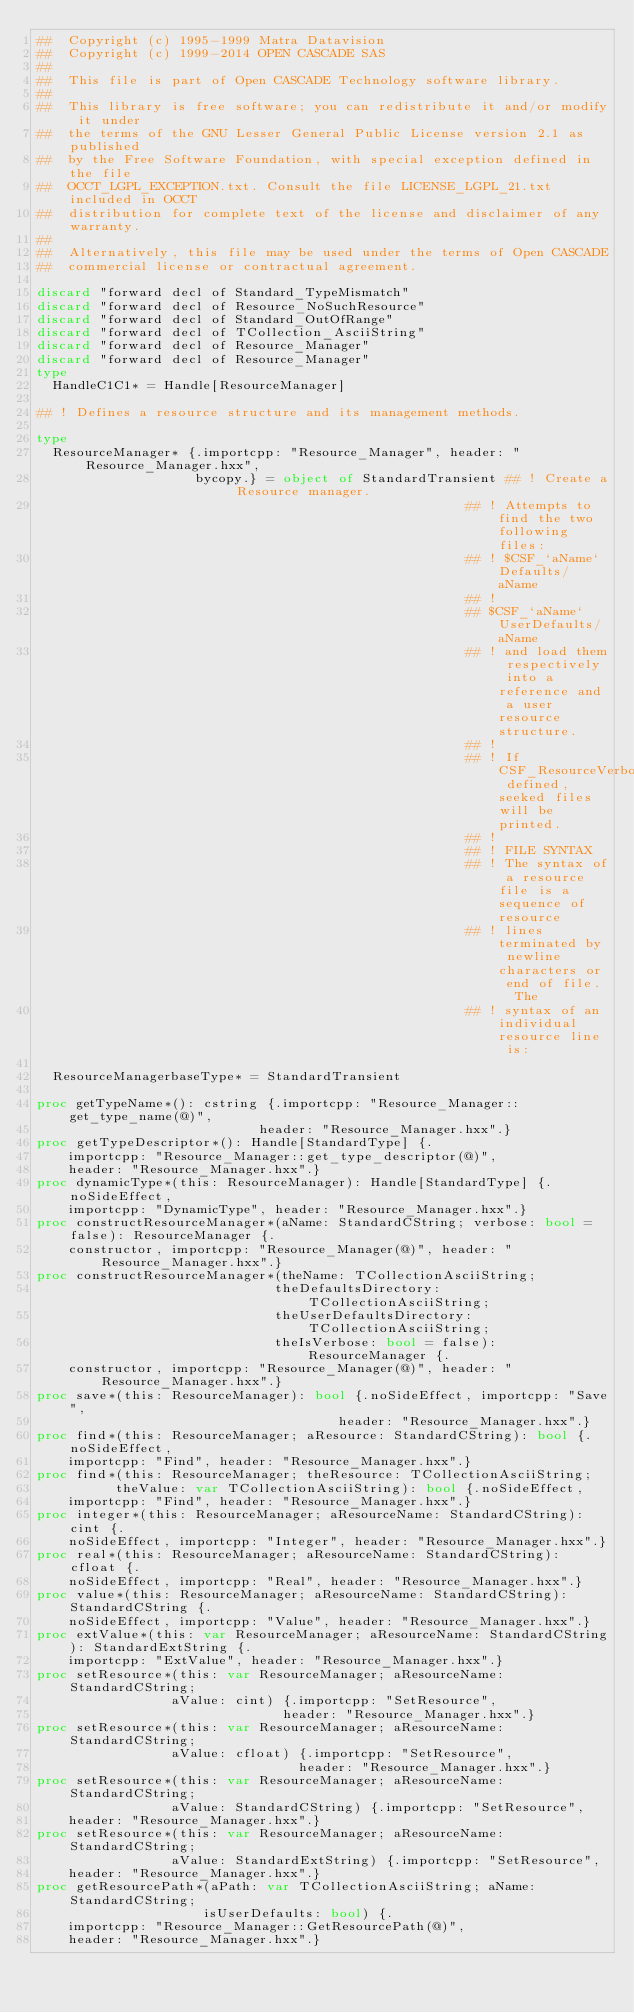Convert code to text. <code><loc_0><loc_0><loc_500><loc_500><_Nim_>##  Copyright (c) 1995-1999 Matra Datavision
##  Copyright (c) 1999-2014 OPEN CASCADE SAS
##
##  This file is part of Open CASCADE Technology software library.
##
##  This library is free software; you can redistribute it and/or modify it under
##  the terms of the GNU Lesser General Public License version 2.1 as published
##  by the Free Software Foundation, with special exception defined in the file
##  OCCT_LGPL_EXCEPTION.txt. Consult the file LICENSE_LGPL_21.txt included in OCCT
##  distribution for complete text of the license and disclaimer of any warranty.
##
##  Alternatively, this file may be used under the terms of Open CASCADE
##  commercial license or contractual agreement.

discard "forward decl of Standard_TypeMismatch"
discard "forward decl of Resource_NoSuchResource"
discard "forward decl of Standard_OutOfRange"
discard "forward decl of TCollection_AsciiString"
discard "forward decl of Resource_Manager"
discard "forward decl of Resource_Manager"
type
  HandleC1C1* = Handle[ResourceManager]

## ! Defines a resource structure and its management methods.

type
  ResourceManager* {.importcpp: "Resource_Manager", header: "Resource_Manager.hxx",
                    bycopy.} = object of StandardTransient ## ! Create a Resource manager.
                                                      ## ! Attempts to find the two following files:
                                                      ## ! $CSF_`aName`Defaults/aName
                                                      ## !
                                                      ## $CSF_`aName`UserDefaults/aName
                                                      ## ! and load them respectively into a reference and a user resource structure.
                                                      ## !
                                                      ## ! If CSF_ResourceVerbose defined, seeked files will be printed.
                                                      ## !
                                                      ## ! FILE SYNTAX
                                                      ## ! The syntax of a resource file is a sequence of resource
                                                      ## ! lines terminated by newline characters or end of file.  The
                                                      ## ! syntax of an individual resource line is:

  ResourceManagerbaseType* = StandardTransient

proc getTypeName*(): cstring {.importcpp: "Resource_Manager::get_type_name(@)",
                            header: "Resource_Manager.hxx".}
proc getTypeDescriptor*(): Handle[StandardType] {.
    importcpp: "Resource_Manager::get_type_descriptor(@)",
    header: "Resource_Manager.hxx".}
proc dynamicType*(this: ResourceManager): Handle[StandardType] {.noSideEffect,
    importcpp: "DynamicType", header: "Resource_Manager.hxx".}
proc constructResourceManager*(aName: StandardCString; verbose: bool = false): ResourceManager {.
    constructor, importcpp: "Resource_Manager(@)", header: "Resource_Manager.hxx".}
proc constructResourceManager*(theName: TCollectionAsciiString;
                              theDefaultsDirectory: TCollectionAsciiString;
                              theUserDefaultsDirectory: TCollectionAsciiString;
                              theIsVerbose: bool = false): ResourceManager {.
    constructor, importcpp: "Resource_Manager(@)", header: "Resource_Manager.hxx".}
proc save*(this: ResourceManager): bool {.noSideEffect, importcpp: "Save",
                                      header: "Resource_Manager.hxx".}
proc find*(this: ResourceManager; aResource: StandardCString): bool {.noSideEffect,
    importcpp: "Find", header: "Resource_Manager.hxx".}
proc find*(this: ResourceManager; theResource: TCollectionAsciiString;
          theValue: var TCollectionAsciiString): bool {.noSideEffect,
    importcpp: "Find", header: "Resource_Manager.hxx".}
proc integer*(this: ResourceManager; aResourceName: StandardCString): cint {.
    noSideEffect, importcpp: "Integer", header: "Resource_Manager.hxx".}
proc real*(this: ResourceManager; aResourceName: StandardCString): cfloat {.
    noSideEffect, importcpp: "Real", header: "Resource_Manager.hxx".}
proc value*(this: ResourceManager; aResourceName: StandardCString): StandardCString {.
    noSideEffect, importcpp: "Value", header: "Resource_Manager.hxx".}
proc extValue*(this: var ResourceManager; aResourceName: StandardCString): StandardExtString {.
    importcpp: "ExtValue", header: "Resource_Manager.hxx".}
proc setResource*(this: var ResourceManager; aResourceName: StandardCString;
                 aValue: cint) {.importcpp: "SetResource",
                               header: "Resource_Manager.hxx".}
proc setResource*(this: var ResourceManager; aResourceName: StandardCString;
                 aValue: cfloat) {.importcpp: "SetResource",
                                 header: "Resource_Manager.hxx".}
proc setResource*(this: var ResourceManager; aResourceName: StandardCString;
                 aValue: StandardCString) {.importcpp: "SetResource",
    header: "Resource_Manager.hxx".}
proc setResource*(this: var ResourceManager; aResourceName: StandardCString;
                 aValue: StandardExtString) {.importcpp: "SetResource",
    header: "Resource_Manager.hxx".}
proc getResourcePath*(aPath: var TCollectionAsciiString; aName: StandardCString;
                     isUserDefaults: bool) {.
    importcpp: "Resource_Manager::GetResourcePath(@)",
    header: "Resource_Manager.hxx".}

























</code> 